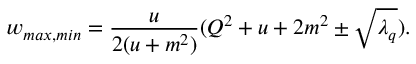Convert formula to latex. <formula><loc_0><loc_0><loc_500><loc_500>w _ { \max , \min } = \frac { u } { 2 ( u + m ^ { 2 } ) } ( Q ^ { 2 } + u + 2 m ^ { 2 } \pm \sqrt { \lambda _ { q } } ) .</formula> 